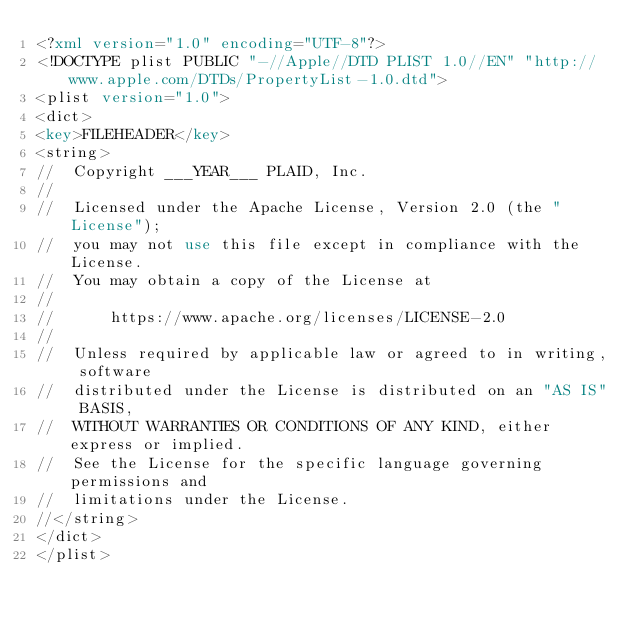<code> <loc_0><loc_0><loc_500><loc_500><_XML_><?xml version="1.0" encoding="UTF-8"?>
<!DOCTYPE plist PUBLIC "-//Apple//DTD PLIST 1.0//EN" "http://www.apple.com/DTDs/PropertyList-1.0.dtd">
<plist version="1.0">
<dict>
<key>FILEHEADER</key>
<string>
//  Copyright ___YEAR___ PLAID, Inc.
//
//  Licensed under the Apache License, Version 2.0 (the "License");
//  you may not use this file except in compliance with the License.
//  You may obtain a copy of the License at
//
//      https://www.apache.org/licenses/LICENSE-2.0
//
//  Unless required by applicable law or agreed to in writing, software
//  distributed under the License is distributed on an "AS IS" BASIS,
//  WITHOUT WARRANTIES OR CONDITIONS OF ANY KIND, either express or implied.
//  See the License for the specific language governing permissions and
//  limitations under the License.
//</string>
</dict>
</plist></code> 